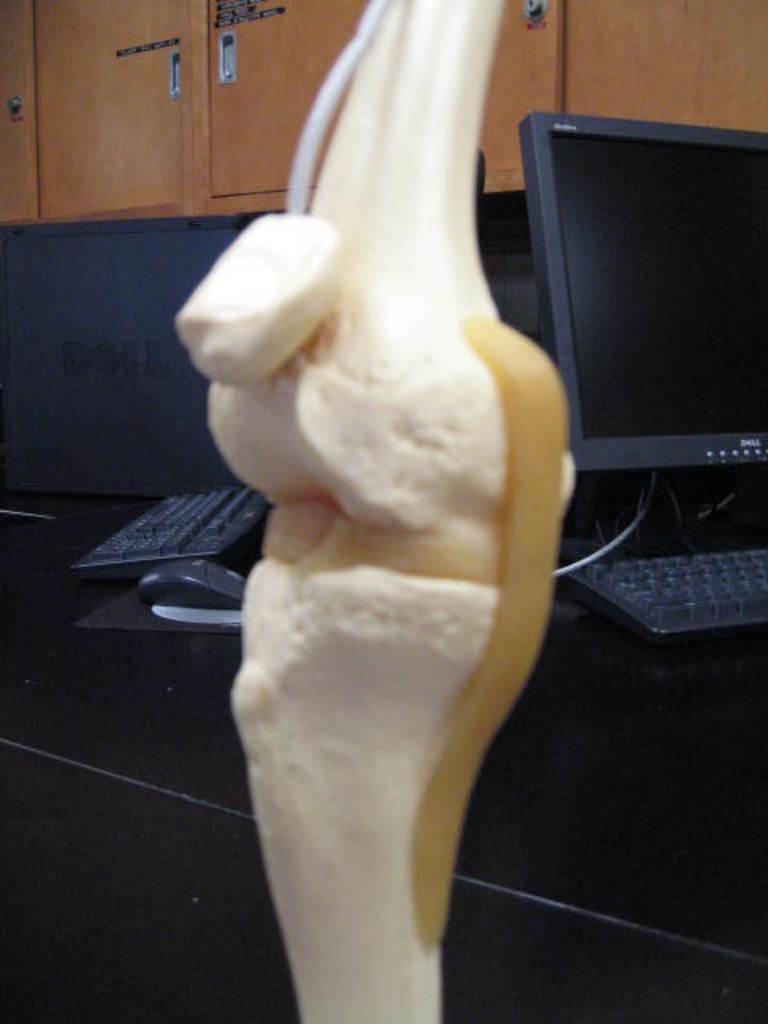Can you describe this image briefly? In the center of the image we can see an object. In the background there are computers, keyboards and a mouse placed on the table. In the background there are cupboards. 